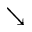<formula> <loc_0><loc_0><loc_500><loc_500>\searrow</formula> 